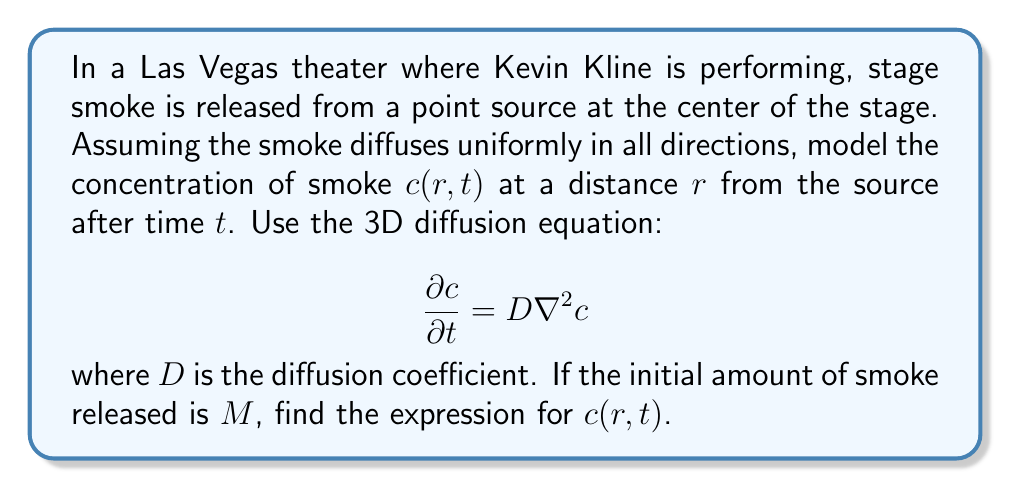Give your solution to this math problem. To solve this problem, we'll follow these steps:

1) The 3D diffusion equation in spherical coordinates (assuming radial symmetry) is:

   $$\frac{\partial c}{\partial t} = D\left(\frac{\partial^2c}{\partial r^2} + \frac{2}{r}\frac{\partial c}{\partial r}\right)$$

2) The initial condition is a point source of smoke, which can be modeled as a Dirac delta function:

   $$c(r,0) = \frac{M}{4\pi r^2}\delta(r)$$

3) The solution to this equation with the given initial condition is:

   $$c(r,t) = \frac{M}{(4\pi Dt)^{3/2}} \exp\left(-\frac{r^2}{4Dt}\right)$$

4) To verify this solution:
   - As $t \to 0$, $c(r,t)$ approaches the initial condition.
   - It satisfies the diffusion equation.
   - The total amount of smoke remains constant: $\int_0^\infty 4\pi r^2 c(r,t) dr = M$

5) This solution represents a Gaussian distribution that spreads out over time, with the peak concentration decreasing and the width increasing.

6) The concentration decreases exponentially with the square of the distance from the source, and also decreases with time as $t^{-3/2}$.

7) The parameter $D$ determines how quickly the smoke spreads: a larger $D$ leads to faster diffusion.
Answer: $$c(r,t) = \frac{M}{(4\pi Dt)^{3/2}} \exp\left(-\frac{r^2}{4Dt}\right)$$ 